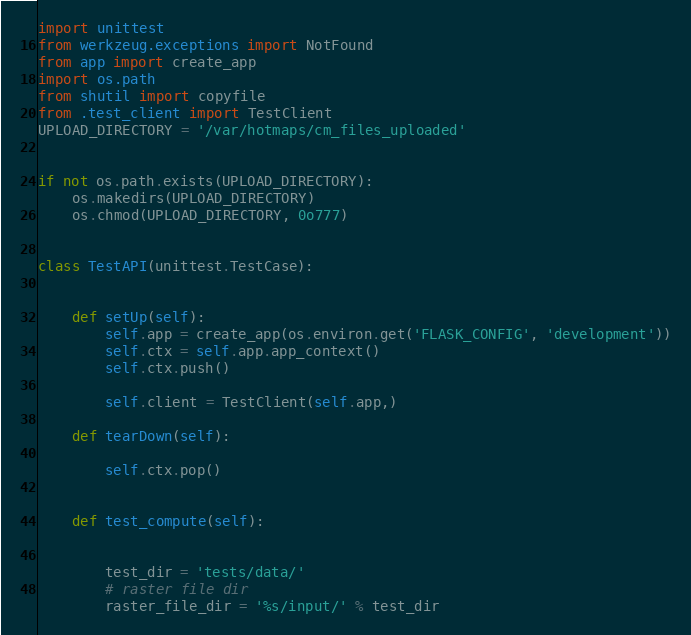Convert code to text. <code><loc_0><loc_0><loc_500><loc_500><_Python_>import unittest
from werkzeug.exceptions import NotFound
from app import create_app
import os.path
from shutil import copyfile
from .test_client import TestClient
UPLOAD_DIRECTORY = '/var/hotmaps/cm_files_uploaded'


if not os.path.exists(UPLOAD_DIRECTORY):
    os.makedirs(UPLOAD_DIRECTORY)
    os.chmod(UPLOAD_DIRECTORY, 0o777)


class TestAPI(unittest.TestCase):


    def setUp(self):
        self.app = create_app(os.environ.get('FLASK_CONFIG', 'development'))
        self.ctx = self.app.app_context()
        self.ctx.push()

        self.client = TestClient(self.app,)

    def tearDown(self):

        self.ctx.pop()


    def test_compute(self):
        
        
        test_dir = 'tests/data/'
        # raster file dir
        raster_file_dir = '%s/input/' % test_dir</code> 